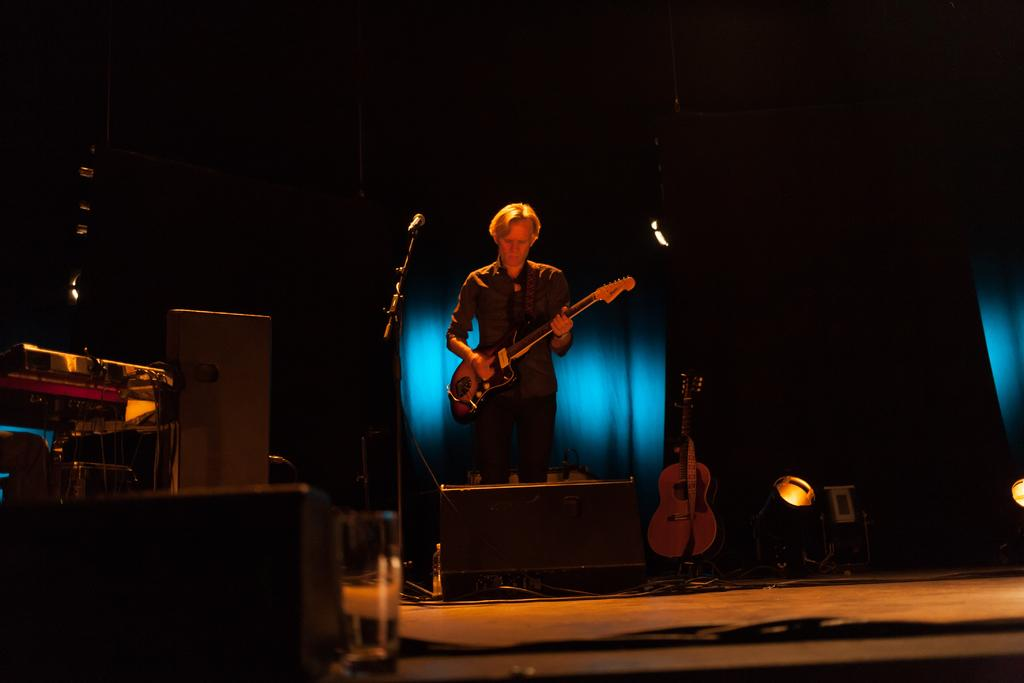Who is the person in the image? There is a man in the image. What is the man holding in his hands? The man is holding a guitar and a microphone. Are there any other musical instruments visible in the image? Yes, there is another guitar on the floor in the image. What is the size of the man's laugh in the image? There is no indication of the man laughing in the image, so it is not possible to determine the size of his laugh. 